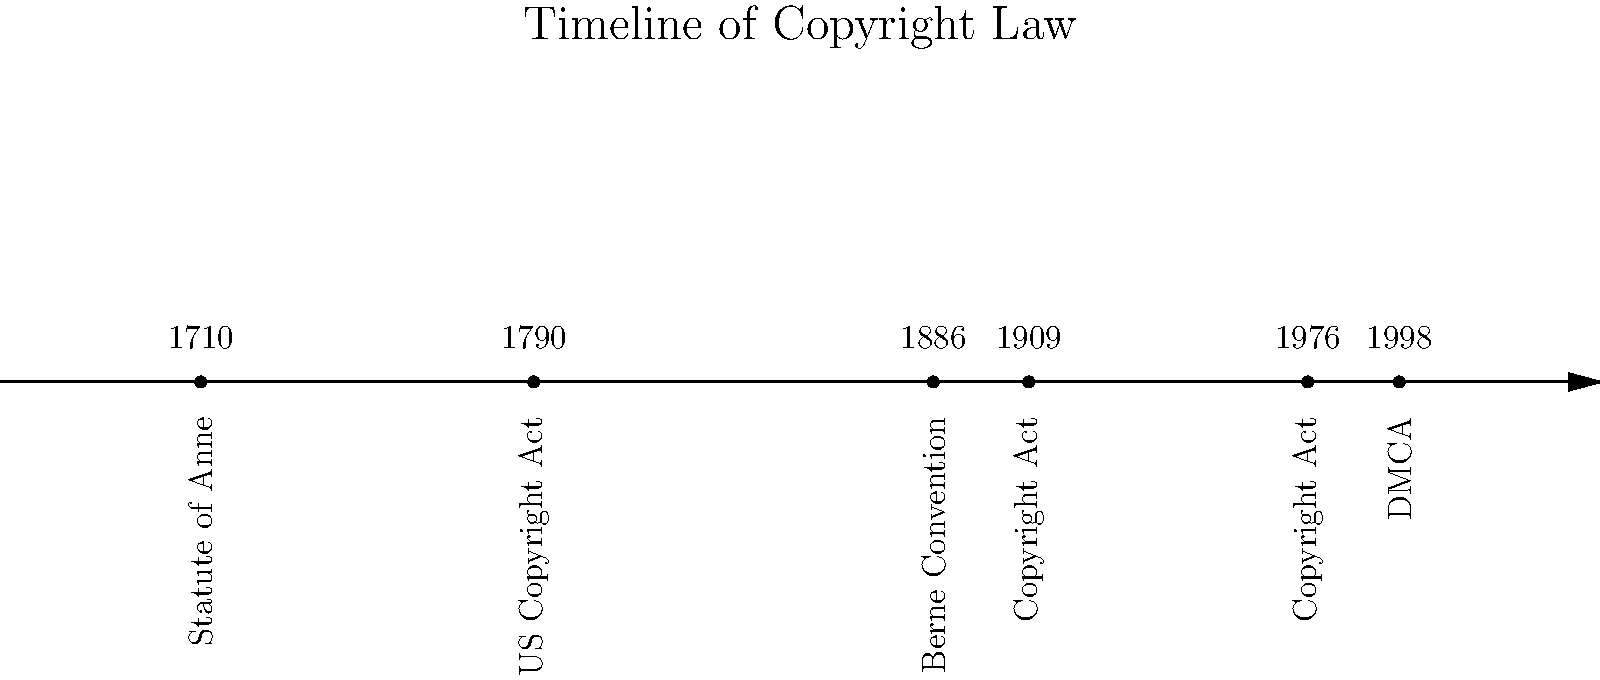Based on the visual timeline of copyright law history, which event marked the first international agreement on copyright protection, and in what year did it occur? To answer this question, we need to analyze the timeline chronologically:

1. 1710: Statute of Anne - This was the first copyright law in the UK, but not an international agreement.
2. 1790: US Copyright Act - This was a national law for the United States, not international.
3. 1886: Berne Convention - This is the key event we're looking for. The Berne Convention was the first international agreement on copyright protection.
4. 1909: Copyright Act - Another US law, not international.
5. 1976: Copyright Act - Another US law, not international.
6. 1998: DMCA (Digital Millennium Copyright Act) - A US law addressing digital copyright issues, not international.

The Berne Convention in 1886 stands out as the first international agreement on copyright protection. It established copyright protection for works of authorship across national borders, setting a standard for international copyright law.
Answer: Berne Convention, 1886 